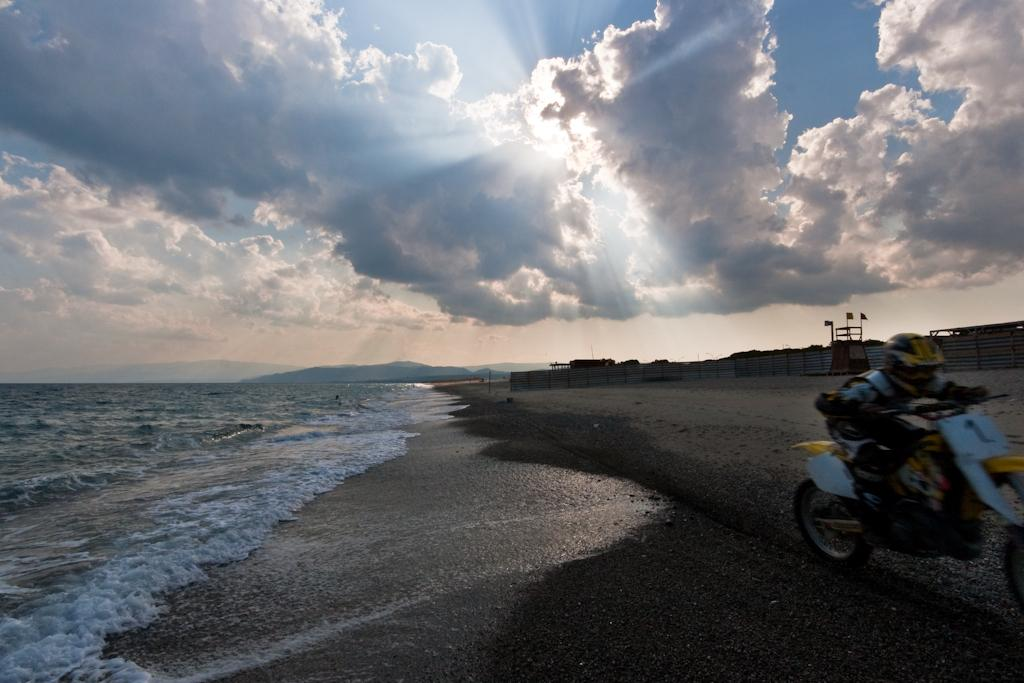What is located on the left side of the image? There is water on the left side of the image. What activity is being performed by the person in the image? The person is riding a bike in the image. What can be seen in the sky in the image? The sky is visible in the image, and clouds are present. How many cows are grazing in the image? There are no cows present in the image. What sound does the bell make in the image? There is no bell present in the image. 